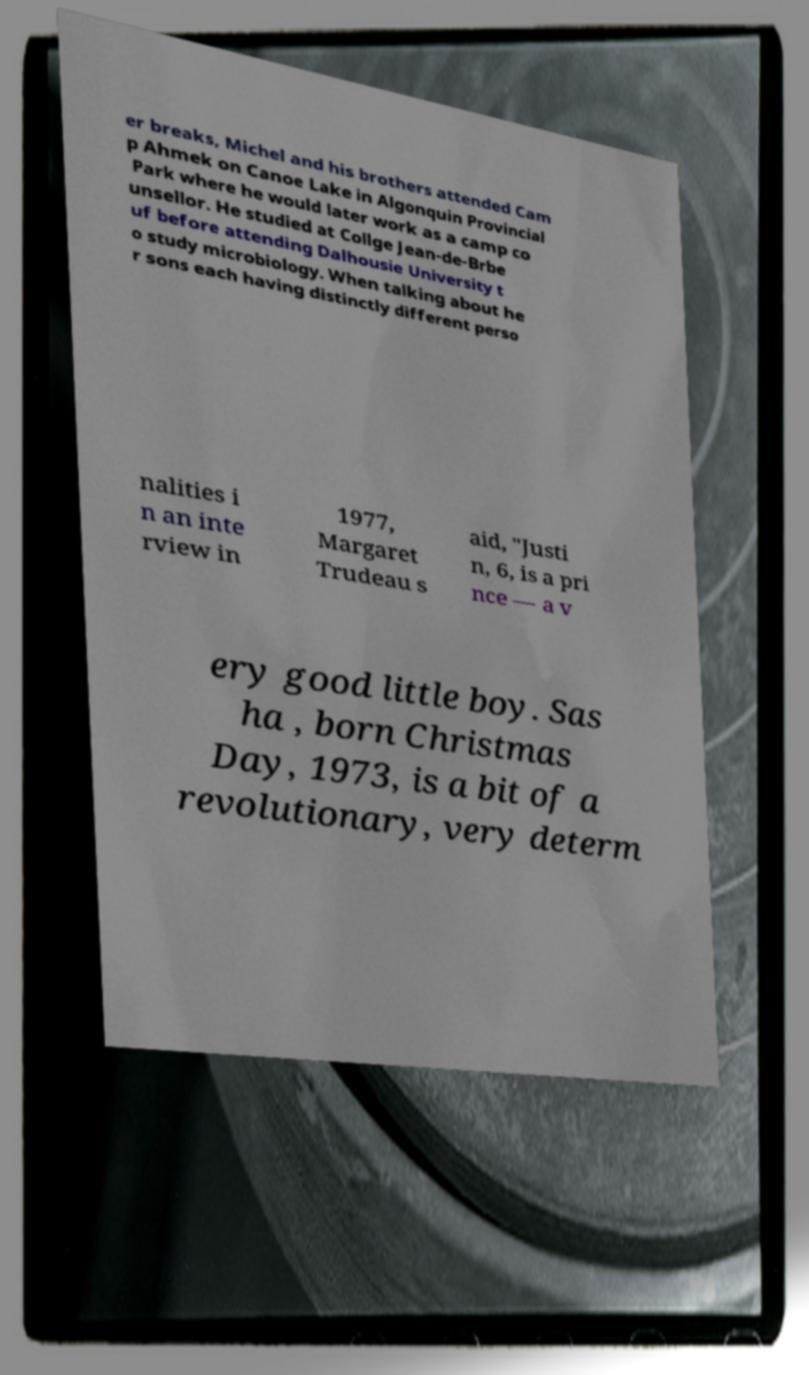What messages or text are displayed in this image? I need them in a readable, typed format. er breaks, Michel and his brothers attended Cam p Ahmek on Canoe Lake in Algonquin Provincial Park where he would later work as a camp co unsellor. He studied at Collge Jean-de-Brbe uf before attending Dalhousie University t o study microbiology. When talking about he r sons each having distinctly different perso nalities i n an inte rview in 1977, Margaret Trudeau s aid, "Justi n, 6, is a pri nce — a v ery good little boy. Sas ha , born Christmas Day, 1973, is a bit of a revolutionary, very determ 